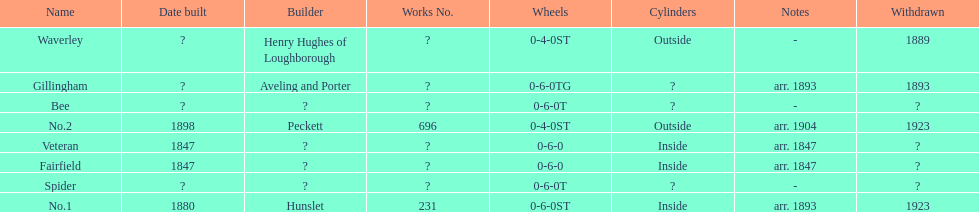Other than fairfield, what else was built in 1847? Veteran. 